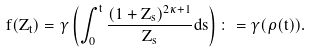<formula> <loc_0><loc_0><loc_500><loc_500>f ( Z _ { t } ) = \gamma \left ( \int _ { 0 } ^ { t } \frac { ( 1 + Z _ { s } ) ^ { 2 \kappa + 1 } } { Z _ { s } } d s \right ) \colon = \gamma ( \rho ( t ) ) .</formula> 